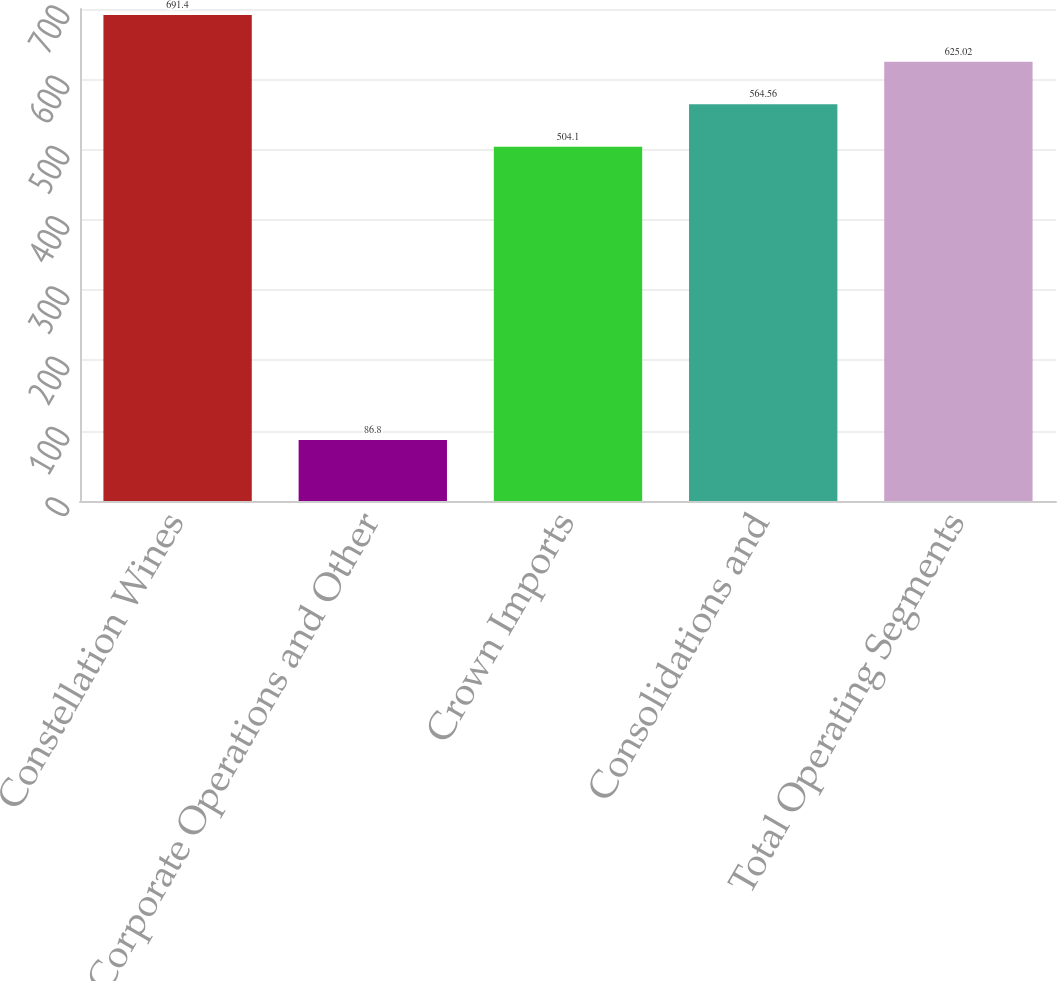Convert chart to OTSL. <chart><loc_0><loc_0><loc_500><loc_500><bar_chart><fcel>Constellation Wines<fcel>Corporate Operations and Other<fcel>Crown Imports<fcel>Consolidations and<fcel>Total Operating Segments<nl><fcel>691.4<fcel>86.8<fcel>504.1<fcel>564.56<fcel>625.02<nl></chart> 